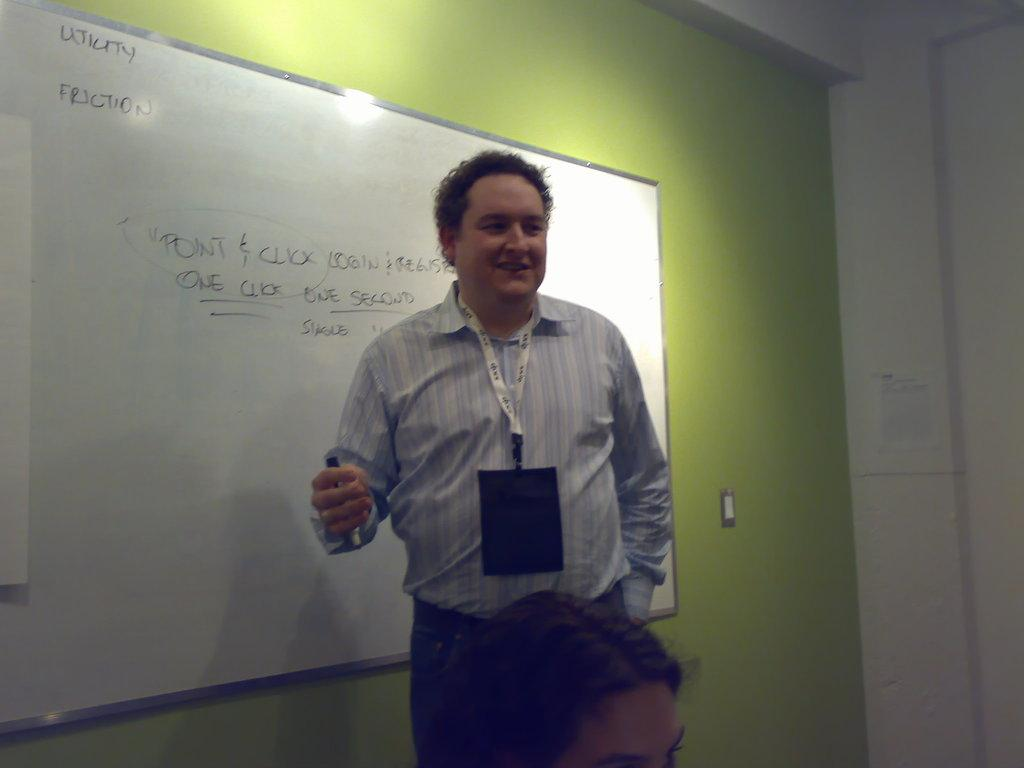<image>
Share a concise interpretation of the image provided. A man is standing near a white board with the words utility and friction near the top. 